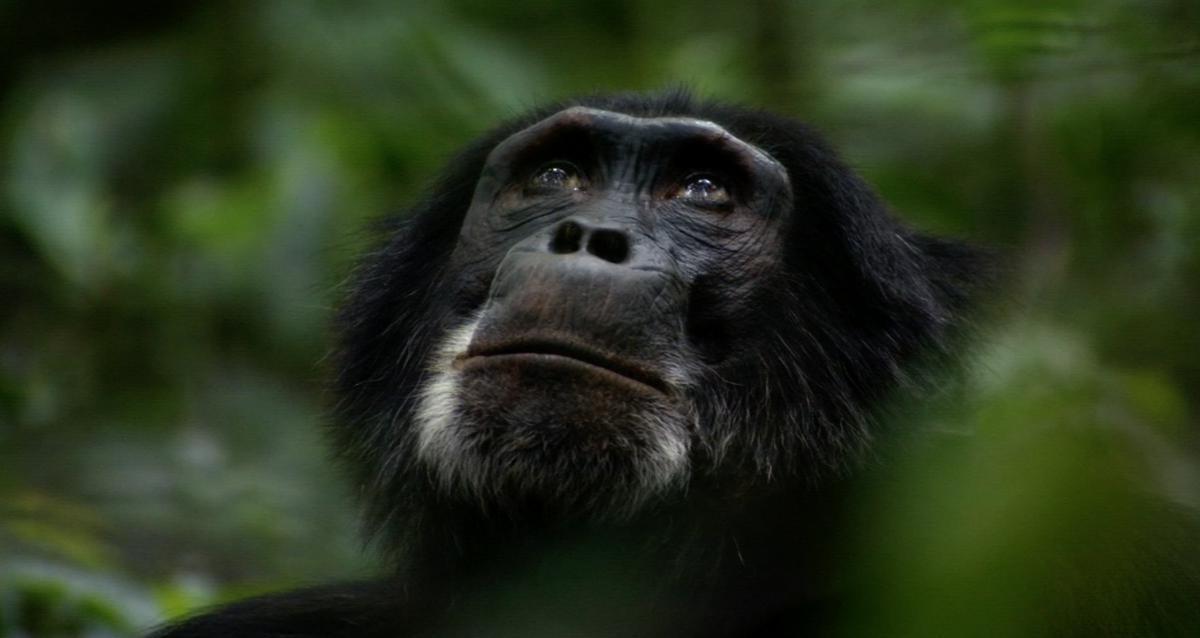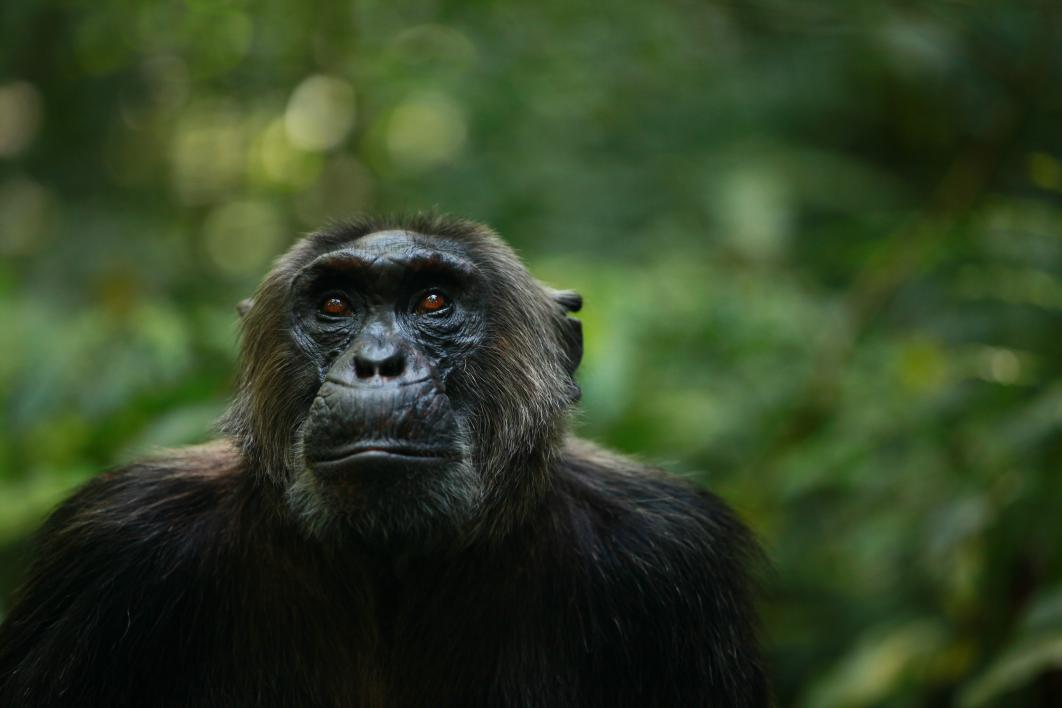The first image is the image on the left, the second image is the image on the right. Analyze the images presented: Is the assertion "Each image contains a single chimpanzee, and the chimps in the left and right images are gazing in the same general direction, but none look straight at the camera with a level gaze." valid? Answer yes or no. Yes. 